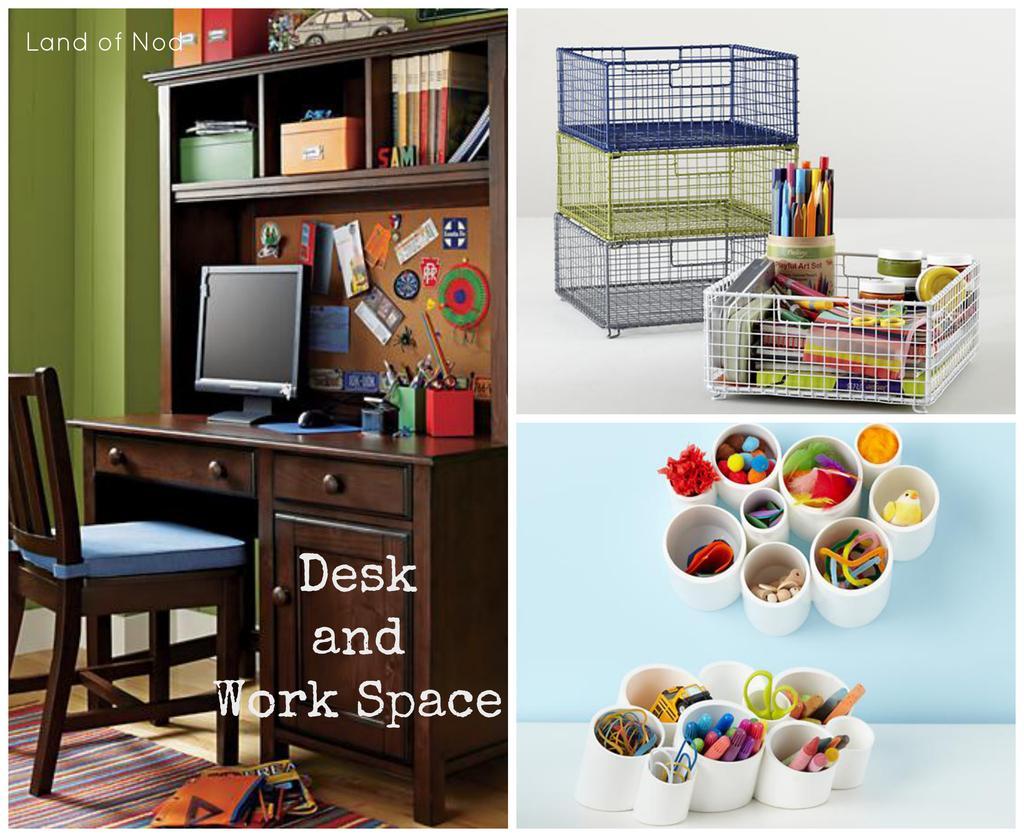In one or two sentences, can you explain what this image depicts? In the image we can see collage photos. On the top right photo we can see metal basket, in it there are other objects. On the bottom right we can see there are cups, in it there are many colorful things. On the left photo we can see the chair, table and on the table there is a system and books kept on the shelf. Here we can see the carpet, floor and the text. 